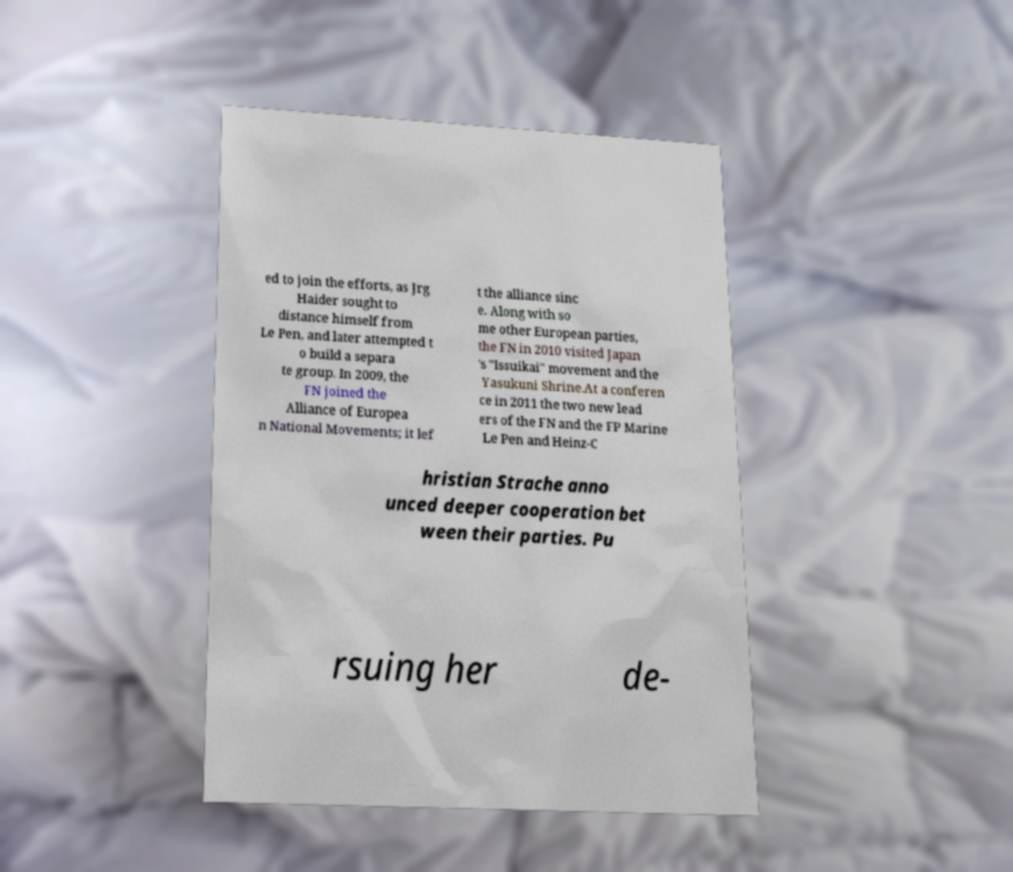Please read and relay the text visible in this image. What does it say? ed to join the efforts, as Jrg Haider sought to distance himself from Le Pen, and later attempted t o build a separa te group. In 2009, the FN joined the Alliance of Europea n National Movements; it lef t the alliance sinc e. Along with so me other European parties, the FN in 2010 visited Japan 's "Issuikai" movement and the Yasukuni Shrine.At a conferen ce in 2011 the two new lead ers of the FN and the FP Marine Le Pen and Heinz-C hristian Strache anno unced deeper cooperation bet ween their parties. Pu rsuing her de- 